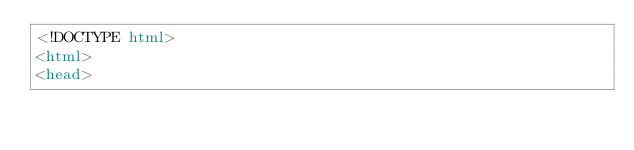<code> <loc_0><loc_0><loc_500><loc_500><_HTML_><!DOCTYPE html>
<html>
<head></code> 